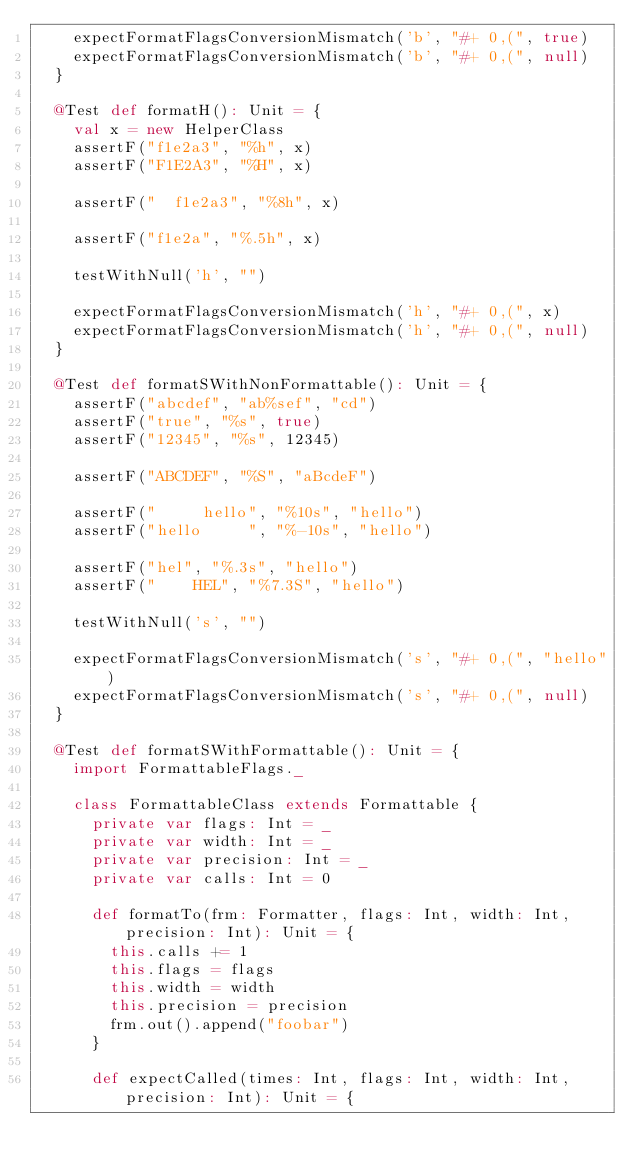Convert code to text. <code><loc_0><loc_0><loc_500><loc_500><_Scala_>    expectFormatFlagsConversionMismatch('b', "#+ 0,(", true)
    expectFormatFlagsConversionMismatch('b', "#+ 0,(", null)
  }

  @Test def formatH(): Unit = {
    val x = new HelperClass
    assertF("f1e2a3", "%h", x)
    assertF("F1E2A3", "%H", x)

    assertF("  f1e2a3", "%8h", x)

    assertF("f1e2a", "%.5h", x)

    testWithNull('h', "")

    expectFormatFlagsConversionMismatch('h', "#+ 0,(", x)
    expectFormatFlagsConversionMismatch('h', "#+ 0,(", null)
  }

  @Test def formatSWithNonFormattable(): Unit = {
    assertF("abcdef", "ab%sef", "cd")
    assertF("true", "%s", true)
    assertF("12345", "%s", 12345)

    assertF("ABCDEF", "%S", "aBcdeF")

    assertF("     hello", "%10s", "hello")
    assertF("hello     ", "%-10s", "hello")

    assertF("hel", "%.3s", "hello")
    assertF("    HEL", "%7.3S", "hello")

    testWithNull('s', "")

    expectFormatFlagsConversionMismatch('s', "#+ 0,(", "hello")
    expectFormatFlagsConversionMismatch('s', "#+ 0,(", null)
  }

  @Test def formatSWithFormattable(): Unit = {
    import FormattableFlags._

    class FormattableClass extends Formattable {
      private var flags: Int = _
      private var width: Int = _
      private var precision: Int = _
      private var calls: Int = 0

      def formatTo(frm: Formatter, flags: Int, width: Int, precision: Int): Unit = {
        this.calls += 1
        this.flags = flags
        this.width = width
        this.precision = precision
        frm.out().append("foobar")
      }

      def expectCalled(times: Int, flags: Int, width: Int, precision: Int): Unit = {</code> 